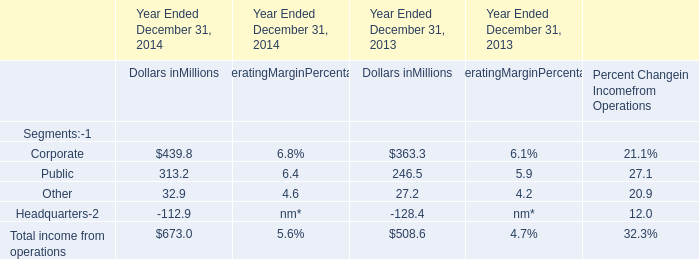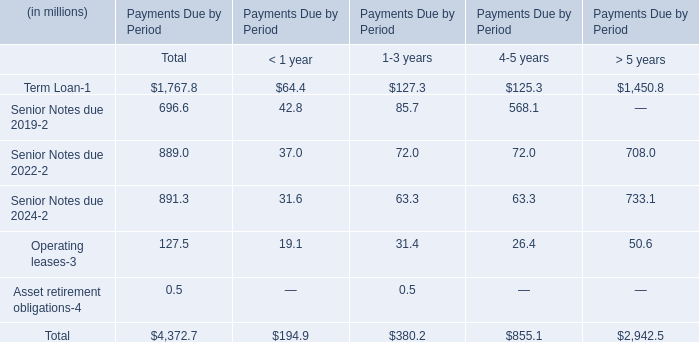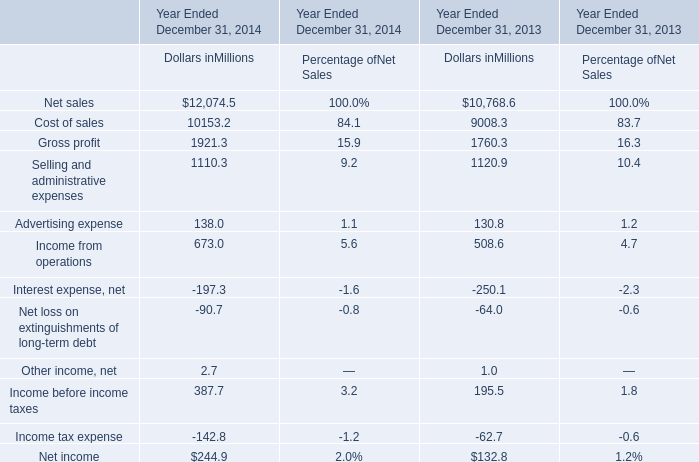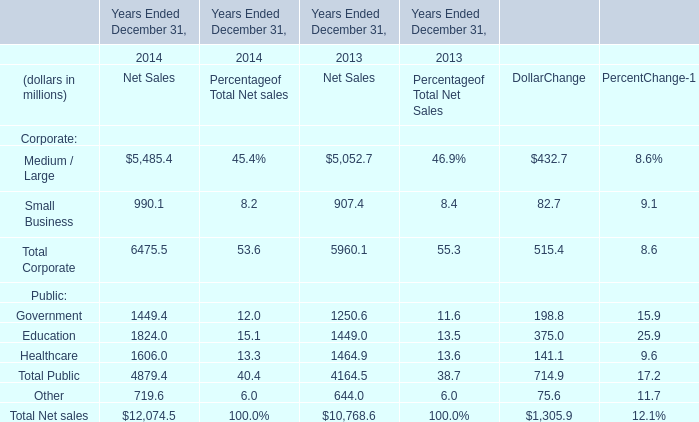What's the sum of the Income from operations for Dollars inMillions in the years where Public for Dollars inMillions is positive? (in million) 
Computations: (673.0 + 508.6)
Answer: 1181.6. 